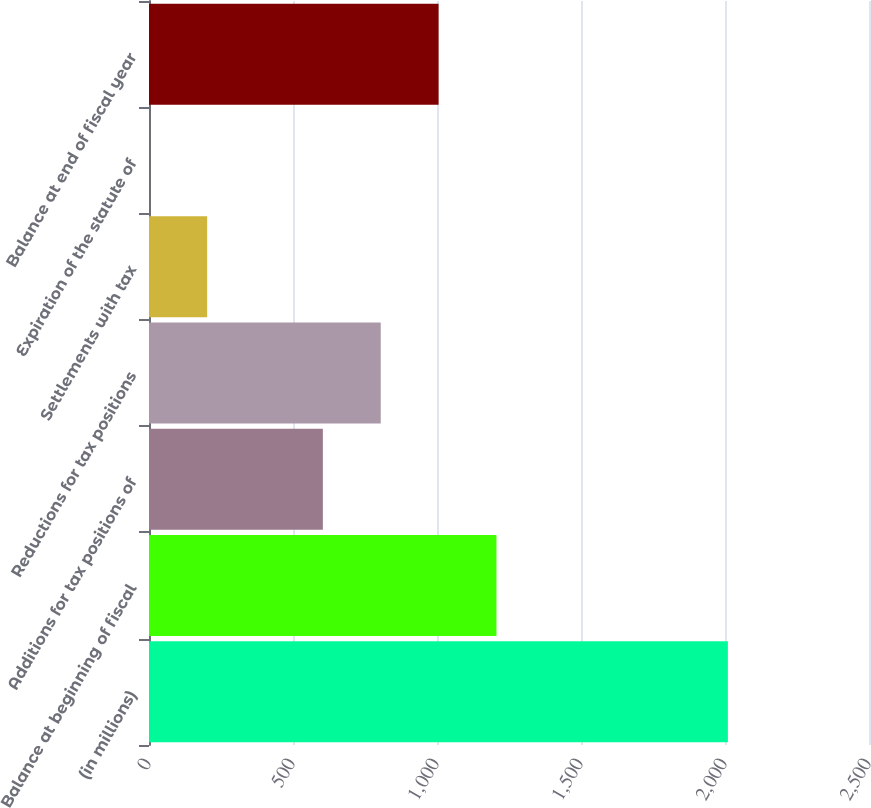Convert chart. <chart><loc_0><loc_0><loc_500><loc_500><bar_chart><fcel>(in millions)<fcel>Balance at beginning of fiscal<fcel>Additions for tax positions of<fcel>Reductions for tax positions<fcel>Settlements with tax<fcel>Expiration of the statute of<fcel>Balance at end of fiscal year<nl><fcel>2010<fcel>1206.4<fcel>603.7<fcel>804.6<fcel>201.9<fcel>1<fcel>1005.5<nl></chart> 